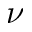<formula> <loc_0><loc_0><loc_500><loc_500>\nu</formula> 